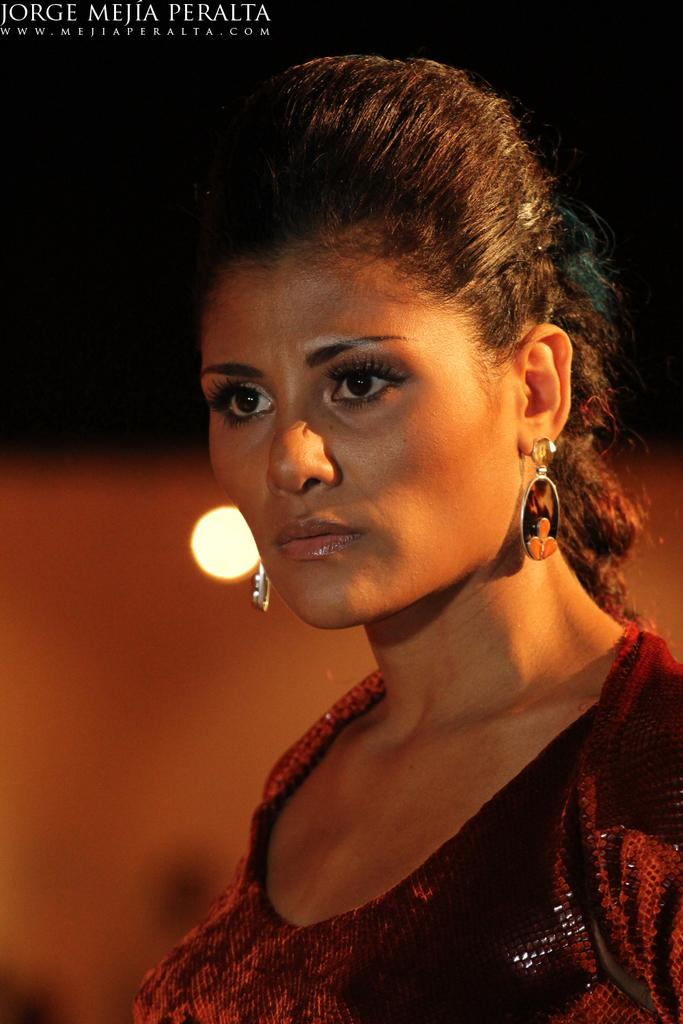What is the main subject on the right side of the image? There is a woman on the right side of the image. What is the woman doing in the image? The woman is watching something. Can you describe any additional features of the image? There is a watermark on the top right of the image, and there is light in the background. What type of rod is the woman using to cause a reaction in the image? There is no rod or any indication of a reaction in the image. The woman is simply watching something. 